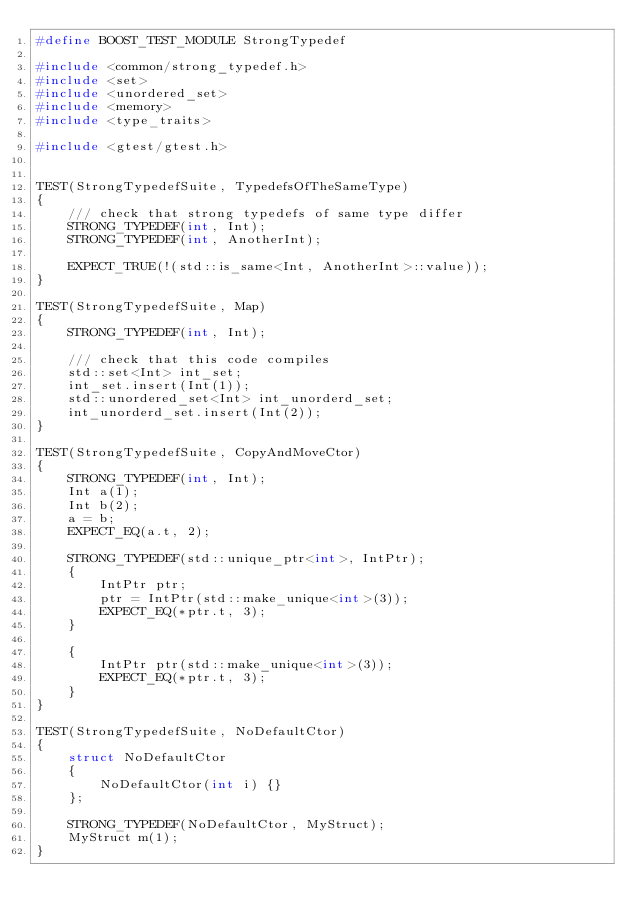Convert code to text. <code><loc_0><loc_0><loc_500><loc_500><_C++_>#define BOOST_TEST_MODULE StrongTypedef

#include <common/strong_typedef.h>
#include <set>
#include <unordered_set>
#include <memory>
#include <type_traits>

#include <gtest/gtest.h>


TEST(StrongTypedefSuite, TypedefsOfTheSameType)
{
    /// check that strong typedefs of same type differ
    STRONG_TYPEDEF(int, Int);
    STRONG_TYPEDEF(int, AnotherInt);

    EXPECT_TRUE(!(std::is_same<Int, AnotherInt>::value));
}

TEST(StrongTypedefSuite, Map)
{
    STRONG_TYPEDEF(int, Int);

    /// check that this code compiles
    std::set<Int> int_set;
    int_set.insert(Int(1));
    std::unordered_set<Int> int_unorderd_set;
    int_unorderd_set.insert(Int(2));
}

TEST(StrongTypedefSuite, CopyAndMoveCtor)
{
    STRONG_TYPEDEF(int, Int);
    Int a(1);
    Int b(2);
    a = b;
    EXPECT_EQ(a.t, 2);

    STRONG_TYPEDEF(std::unique_ptr<int>, IntPtr);
    {
        IntPtr ptr;
        ptr = IntPtr(std::make_unique<int>(3));
        EXPECT_EQ(*ptr.t, 3);
    }

    {
        IntPtr ptr(std::make_unique<int>(3));
        EXPECT_EQ(*ptr.t, 3);
    }
}

TEST(StrongTypedefSuite, NoDefaultCtor)
{
    struct NoDefaultCtor
    {
        NoDefaultCtor(int i) {}
    };

    STRONG_TYPEDEF(NoDefaultCtor, MyStruct);
    MyStruct m(1);
}
</code> 